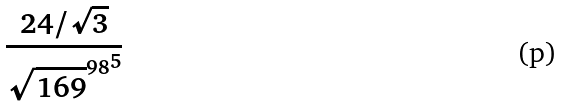Convert formula to latex. <formula><loc_0><loc_0><loc_500><loc_500>\frac { 2 4 / \sqrt { 3 } } { { \sqrt { 1 6 9 } ^ { 9 8 } } ^ { 5 } }</formula> 